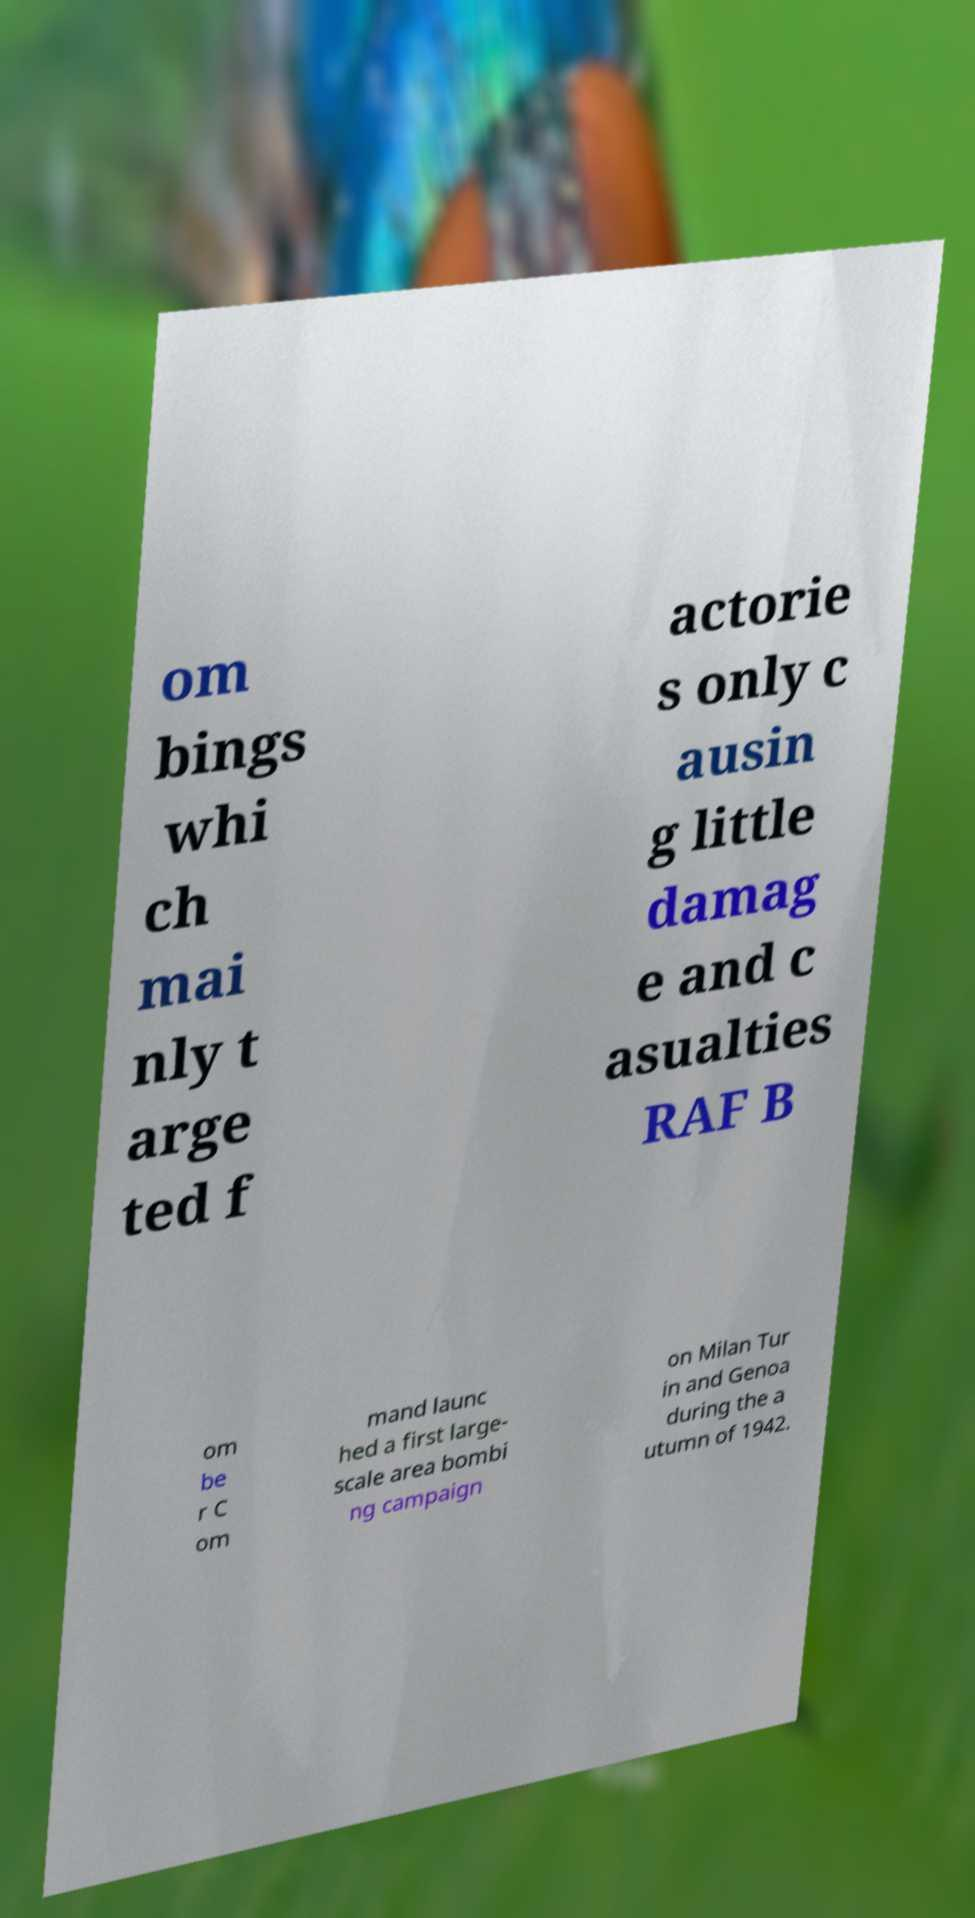There's text embedded in this image that I need extracted. Can you transcribe it verbatim? om bings whi ch mai nly t arge ted f actorie s only c ausin g little damag e and c asualties RAF B om be r C om mand launc hed a first large- scale area bombi ng campaign on Milan Tur in and Genoa during the a utumn of 1942. 